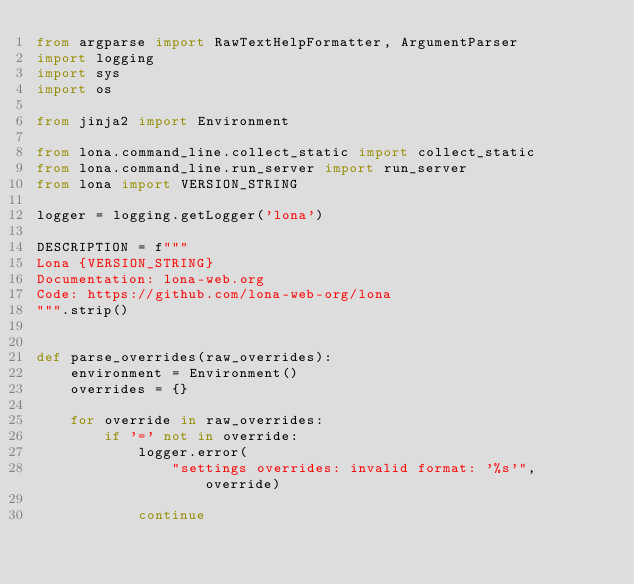Convert code to text. <code><loc_0><loc_0><loc_500><loc_500><_Python_>from argparse import RawTextHelpFormatter, ArgumentParser
import logging
import sys
import os

from jinja2 import Environment

from lona.command_line.collect_static import collect_static
from lona.command_line.run_server import run_server
from lona import VERSION_STRING

logger = logging.getLogger('lona')

DESCRIPTION = f"""
Lona {VERSION_STRING}
Documentation: lona-web.org
Code: https://github.com/lona-web-org/lona
""".strip()


def parse_overrides(raw_overrides):
    environment = Environment()
    overrides = {}

    for override in raw_overrides:
        if '=' not in override:
            logger.error(
                "settings overrides: invalid format: '%s'", override)

            continue
</code> 